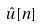<formula> <loc_0><loc_0><loc_500><loc_500>\hat { u } [ n ]</formula> 